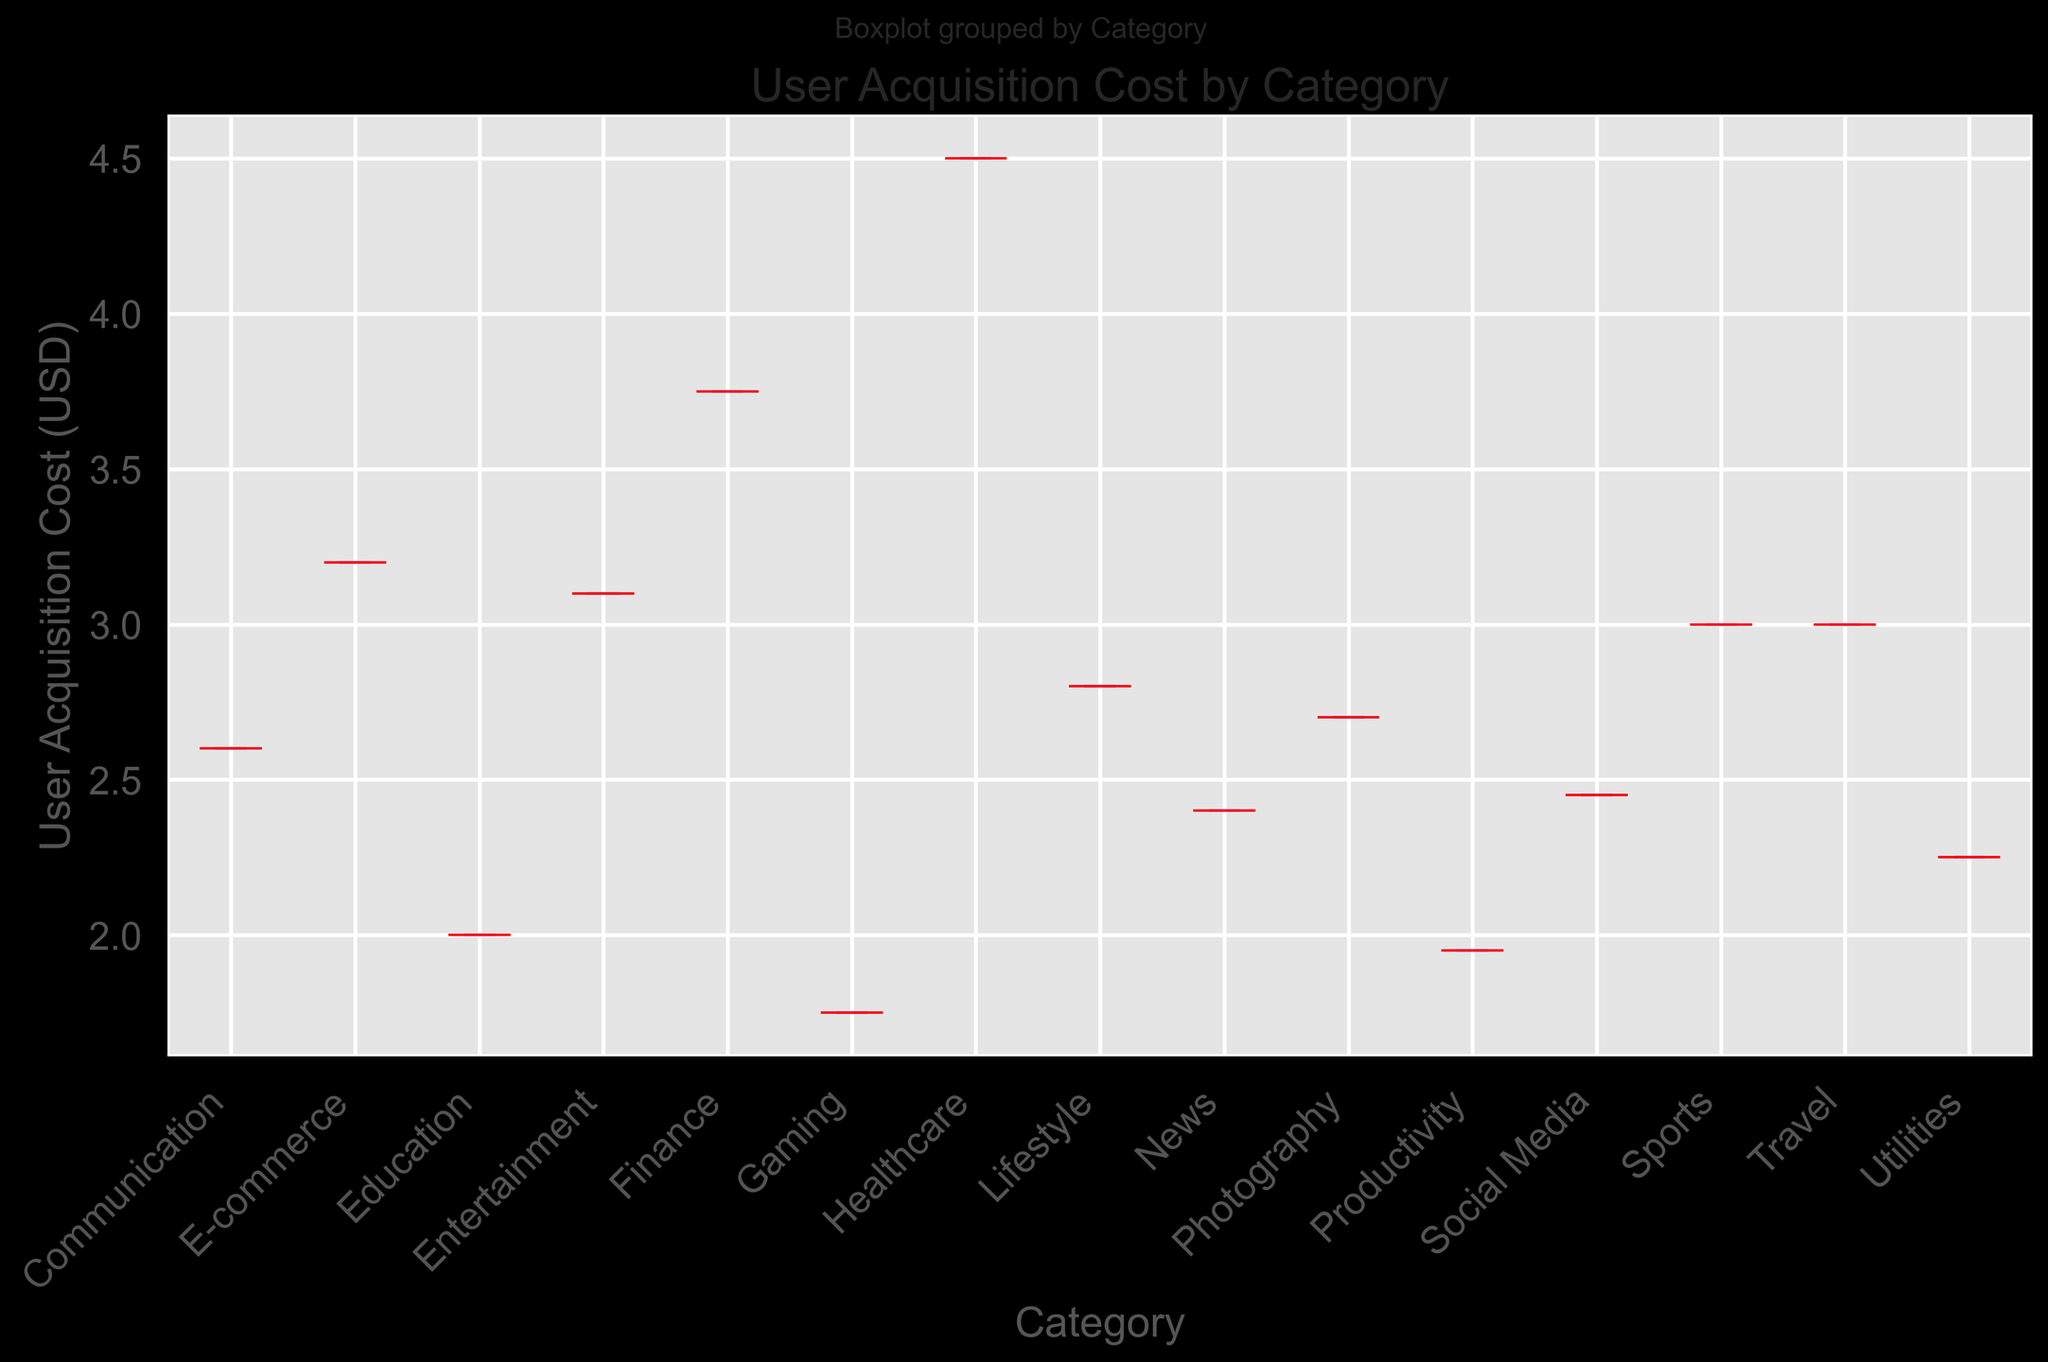Which category has the highest median user acquisition cost? To determine the category with the highest median user acquisition cost, look at the red line (which represents the median) inside each boxplot and identify the one that is the highest.
Answer: Healthcare How does the median user acquisition cost for Gaming compare to Social Media? Compare the red lines (medians) in the boxplots for Gaming and Social Media. By this visual inspection, you can see which one is higher or lower.
Answer: Gaming is lower Which category has the lowest user acquisition cost whisker? The whiskers represent the range of the data excluding outliers. Identify which category has the lowest bottom whisker.
Answer: Gaming What is the average user acquisition cost for categories with a median cost above $3? For categories with a median line above $3 (E-commerce, Healthcare, Finance, and Sports), add their median values and divide by the number of these categories: (3.2 + 4.5 + 3.75 + 3) / 4.
Answer: 3.61 How does the interquartile range (IQR) of Finance compare to Travel? The IQR is the range between the top and bottom of the box. Compare the height of the boxes for Finance and Travel to see which has a wider IQR.
Answer: Finance is wider Are there any outliers in the User Acquisition Costs data, and if so, which categories do they belong to? Outliers are typically indicated by individual points outside the whiskers of the boxplot. Identify categories where such points occur.
Answer: No outliers Which category has the widest range of user acquisition costs (i.e., the distance between the top and bottom whiskers)? To find this, compare the length between the top and bottom whiskers across all categories.
Answer: Healthcare How does the user acquisition cost distribution for Utilities compare to Productivity? Look at the boxplot characteristics (median, IQR, range) for both Utilities and Productivity and compare them accordingly.
Answer: Utilities has a slightly higher median and similar range Is there a category where the median is very close to one of the quartiles? Which one? Find the category where the red median line is very close to the top or bottom of the box.
Answer: Education (close to the bottom quartile) What does the boxplot for E-commerce tell us about its user acquisition costs compared to the other categories? Analyze the position of the box, median, whiskers, and size. Note the high median and wide IQR, indicating higher and more variable acquisition costs.
Answer: High median and wide IQR 